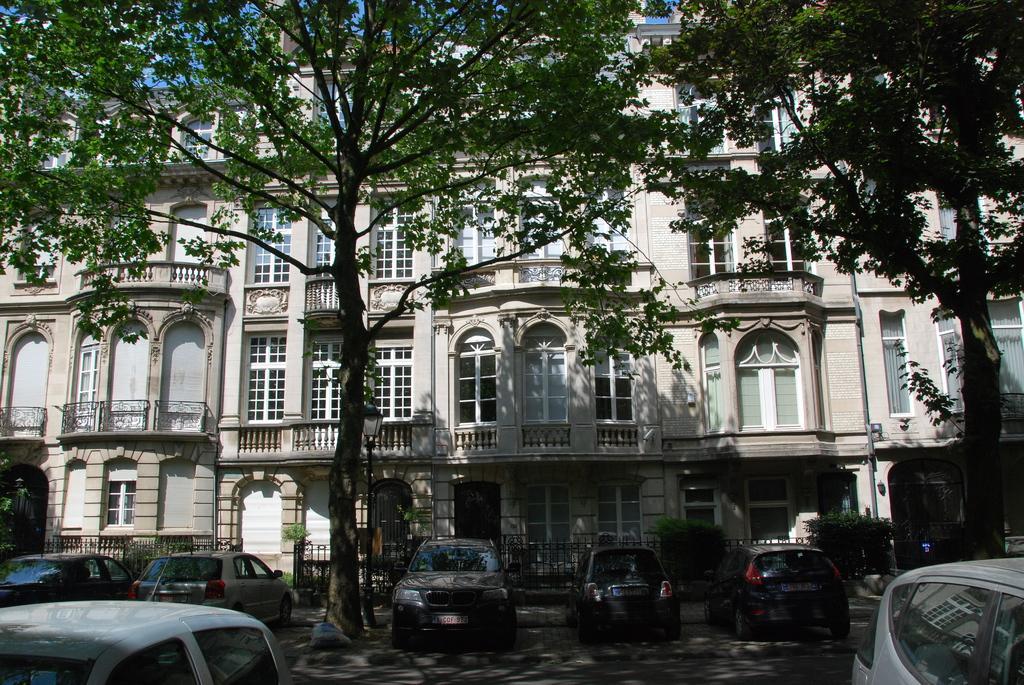Could you give a brief overview of what you see in this image? In this picture we can see trees, building, grilles, plants, vehicles and sky. 